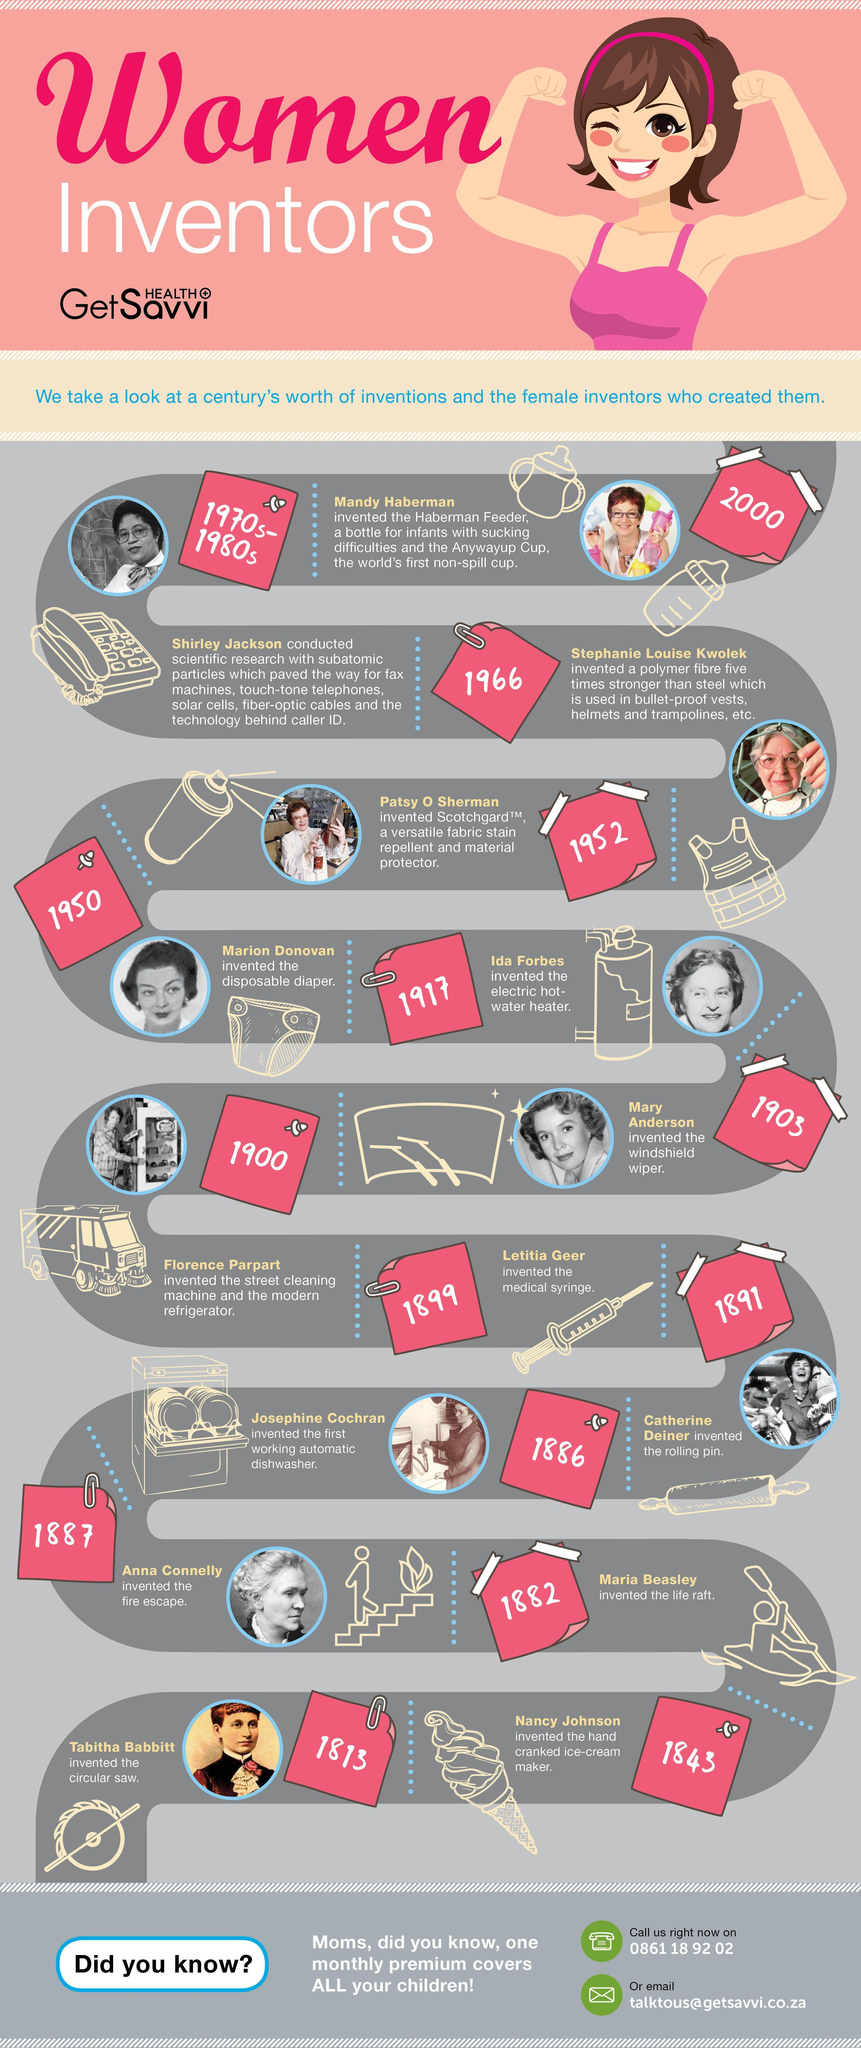Who invented the first automatic dishwasher?
Answer the question with a short phrase. Josephine Cochran Who invented the medical syringe? Letitia Geer Whose invention is the electric hot-water heater? Ida Forbes In which year did Catherine Deiner invent the rolling pin? 1891 Who invented the polymer fibre used in bulletproof vests, helmets and trampolines? Stephanie Louise Kwolek What was invented by Anna Connelly? the fire escape Who invented the disposable diaper? Marion Donovan Whose research paved the way for solar cells, fiber-optic cables, fax machines and caller-id technology? Shirley Jackson Who invented the hand cranked ice-cream maker? Nancy Johnson During which year did Florence Parpart invent the street cleaning machine and the modern refrigerator? 1900 